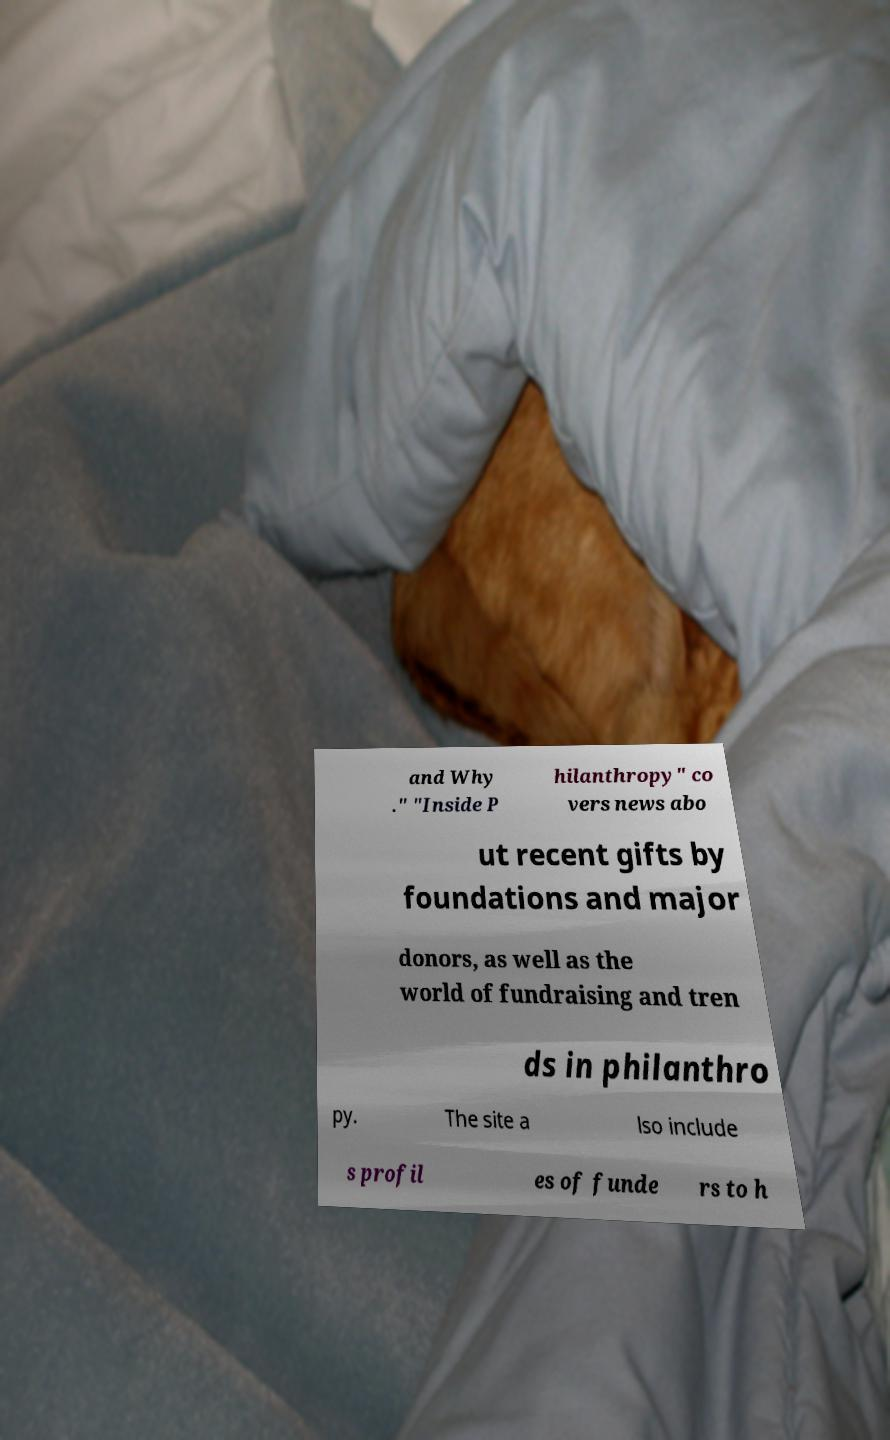Please identify and transcribe the text found in this image. and Why ." "Inside P hilanthropy" co vers news abo ut recent gifts by foundations and major donors, as well as the world of fundraising and tren ds in philanthro py. The site a lso include s profil es of funde rs to h 